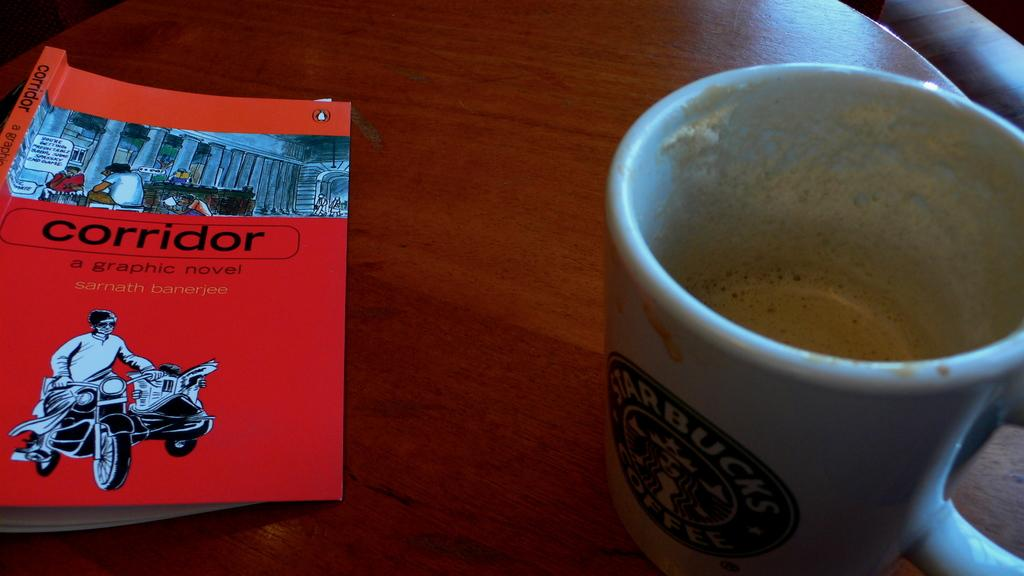<image>
Present a compact description of the photo's key features. A mostly empty starbucks mug with a red book next to it. 